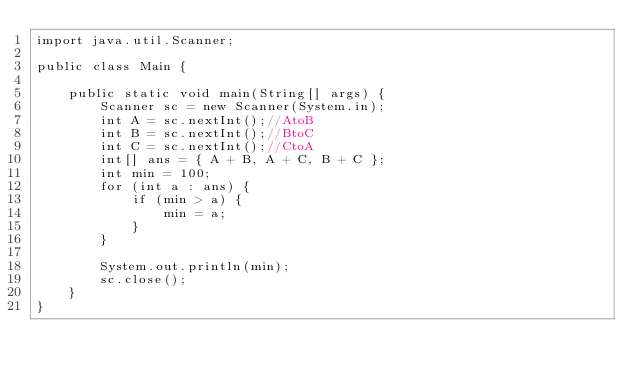Convert code to text. <code><loc_0><loc_0><loc_500><loc_500><_Java_>import java.util.Scanner;

public class Main {

	public static void main(String[] args) {
		Scanner sc = new Scanner(System.in);
		int A = sc.nextInt();//AtoB
		int B = sc.nextInt();//BtoC
		int C = sc.nextInt();//CtoA
		int[] ans = { A + B, A + C, B + C };
		int min = 100;
		for (int a : ans) {
			if (min > a) {
				min = a;
			}
		}

		System.out.println(min);
		sc.close();
	}
}
</code> 